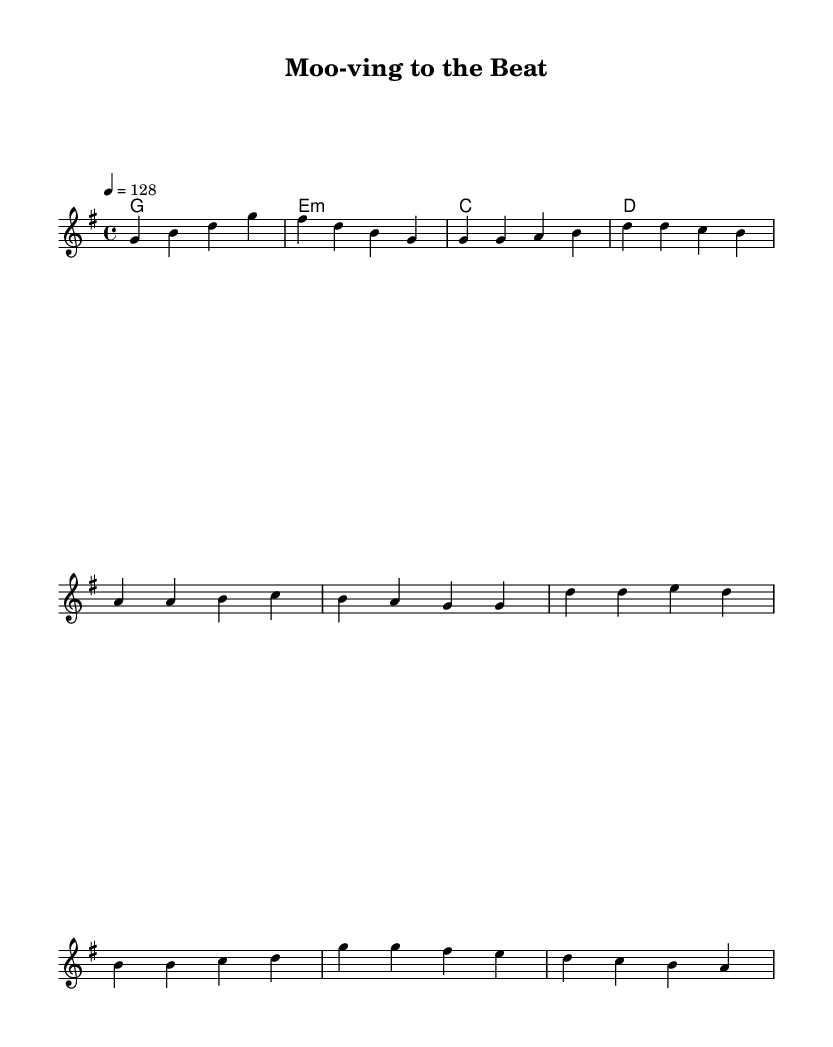What is the key signature of this music? The key signature is G major, which has one sharp (F#). This is indicated by the presence of the sharp symbol on the staff.
Answer: G major What is the time signature of this piece? The time signature is 4/4, which means there are four beats per measure and the quarter note gets one beat. This is explicitly written at the beginning of the score.
Answer: 4/4 What is the tempo marking of this music? The tempo marking is 128 beats per minute, indicated by the notation "4 = 128." This tells musicians how fast to play the piece.
Answer: 128 How many measures are in the chorus? The chorus consists of four measures, as reflected in the layout of the music where the line breaks after four measures of notes and lyrics.
Answer: 4 What dairy-themed words are included in the lyrics? The lyrics contain the words "Dairy," "Milk," and "cheesy," which are directly related to dairy products, forming a connection between the theme of the song and the lyrics.
Answer: Dairy, Milk, cheesy How does the harmony change in the chorus compared to the verse? In the chorus, the harmony transitions from G major in the verse to a combination of G major, E minor, C major, and D major. This contrast typically aims to create a different emotional feeling and energy level in the chorus compared to the verse.
Answer: G, E minor, C, D What farm animal is prominently featured in the chorus? The term "Moo" is prominently featured in the chorus, representing the sound of a cow, emphasizing the farm theme of the song.
Answer: Moo 